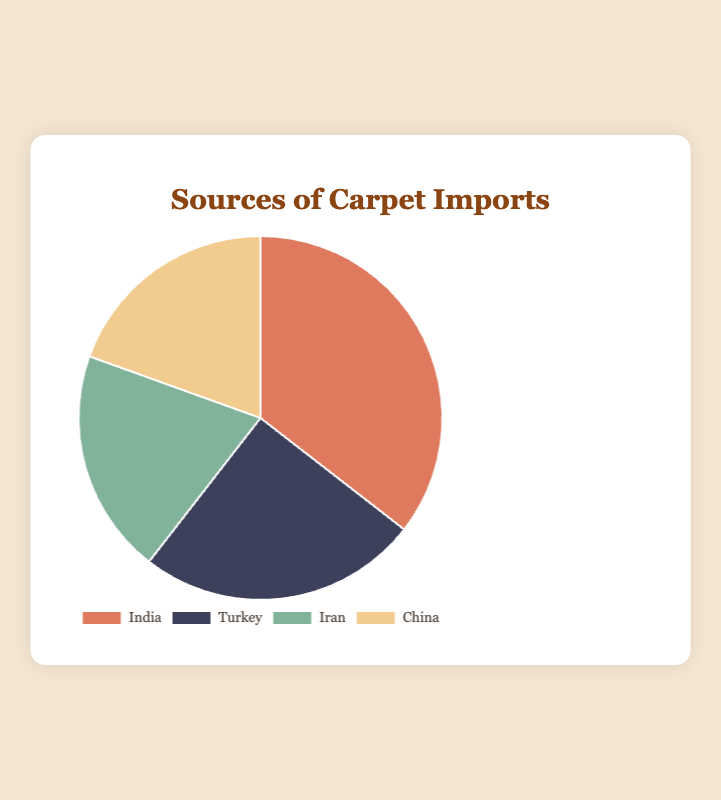What percentage of carpet imports come from India? India contributes 35.5% of the total carpet imports. This is directly shown in the pie chart.
Answer: 35.5% Which country contributes the least to carpet imports? By looking at the percentages in the pie chart, China contributes the least with 19.5%.
Answer: China Compare the imports from Turkey and Iran. Which country has a higher percentage and by how much? Turkey has a higher percentage than Iran. Turkey's import percentage is 25.0%, whereas Iran's is 20.0%. The difference is 25.0% - 20.0% = 5.0%.
Answer: Turkey by 5.0% Add up the percentages for the top two importing countries. What is the total? The top two importing countries are India (35.5%) and Turkey (25.0%). Adding these together: 35.5 + 25.0 = 60.5%.
Answer: 60.5% Which section of the pie chart is represented by the color green? The pie chart shows that the section for Iran is represented by the color green.
Answer: Iran If you combine the import percentages from China and Iran, how does it compare to India's import percentage? China has 19.5% and Iran has 20.0%, combined they make 19.5% + 20.0% = 39.5%. India's import percentage is 35.5%. Comparing, 39.5% > 35.5%.
Answer: Combined is higher by 4% What is the difference in import percentage between the country with the highest and the country with the lowest imports? The highest import percentage is from India (35.5%), and the lowest is from China (19.5%). The difference is 35.5% - 19.5% = 16.0%.
Answer: 16.0% Rank the countries by their import percentages from highest to lowest. India (35.5%), Turkey (25.0%), Iran (20.0%), China (19.5%). This ranking is based on the given percentages in descending order.
Answer: India, Turkey, Iran, China 